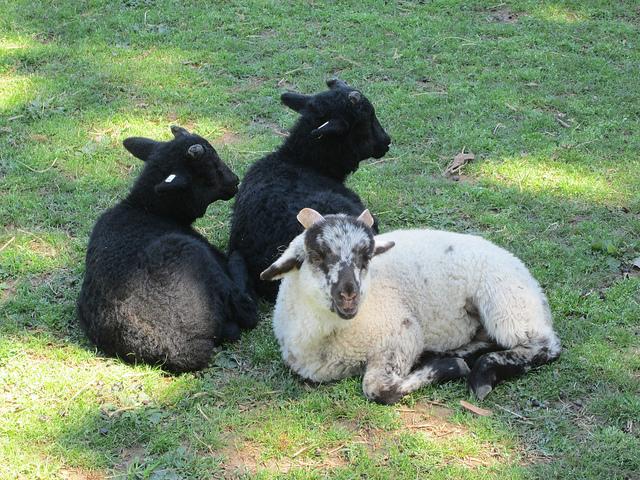Which of these animals has a bad reputation?
Short answer required. Black sheep. Which one of these animal is a male?
Concise answer only. White. Are these animals old or young?
Keep it brief. Young. 